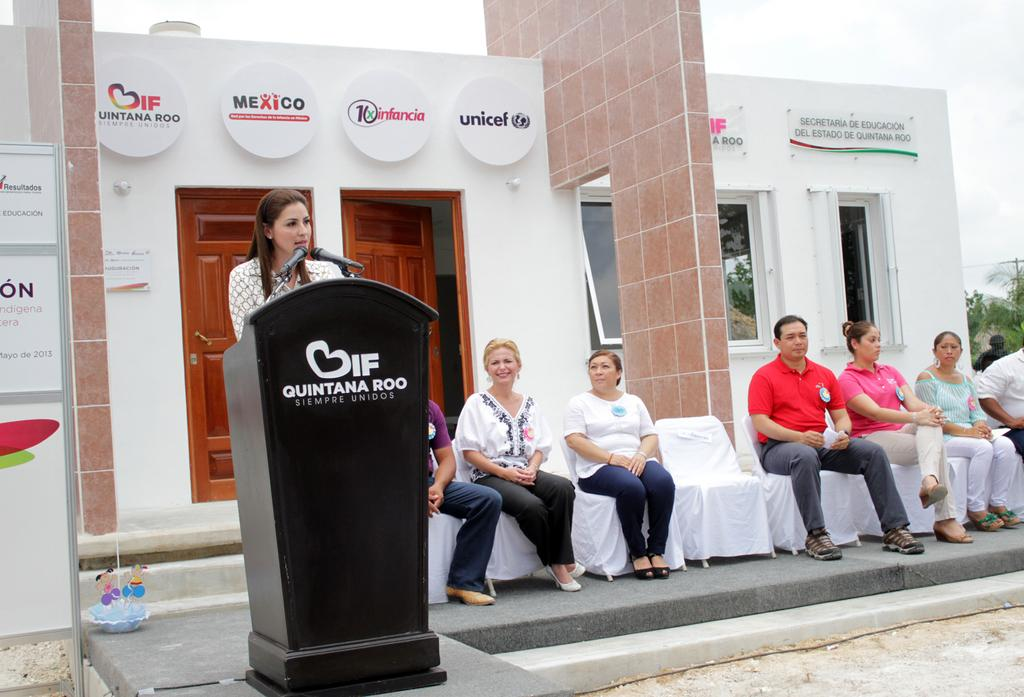<image>
Render a clear and concise summary of the photo. Different people from sponsors that are watching a woman speak at a podium, text says If Quintana Roo Siempre Unidos. 